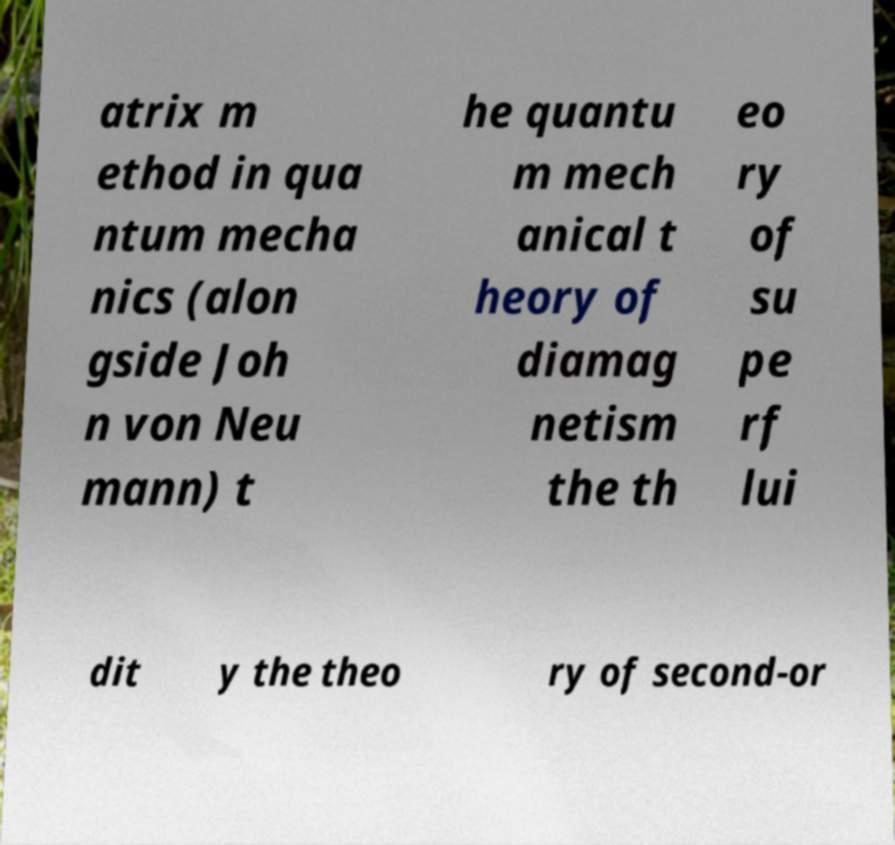Could you assist in decoding the text presented in this image and type it out clearly? atrix m ethod in qua ntum mecha nics (alon gside Joh n von Neu mann) t he quantu m mech anical t heory of diamag netism the th eo ry of su pe rf lui dit y the theo ry of second-or 